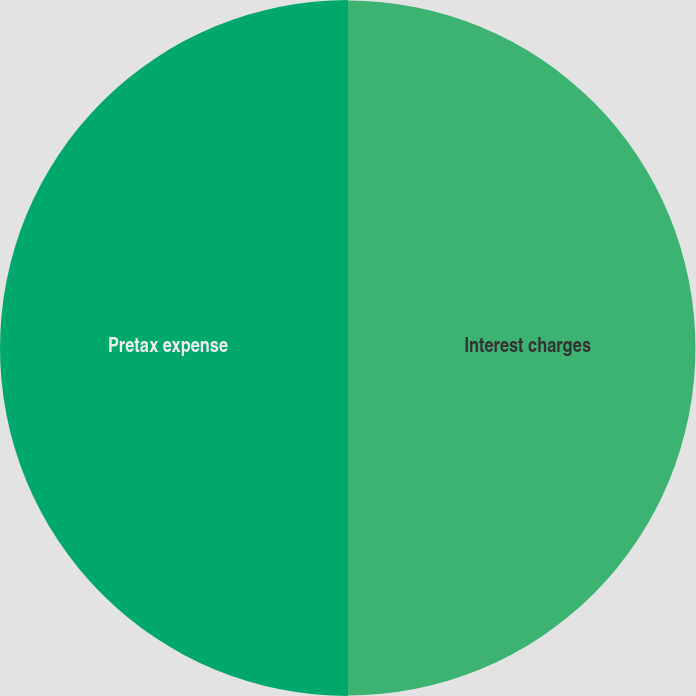Convert chart to OTSL. <chart><loc_0><loc_0><loc_500><loc_500><pie_chart><fcel>Interest charges<fcel>Pretax expense<nl><fcel>49.96%<fcel>50.04%<nl></chart> 